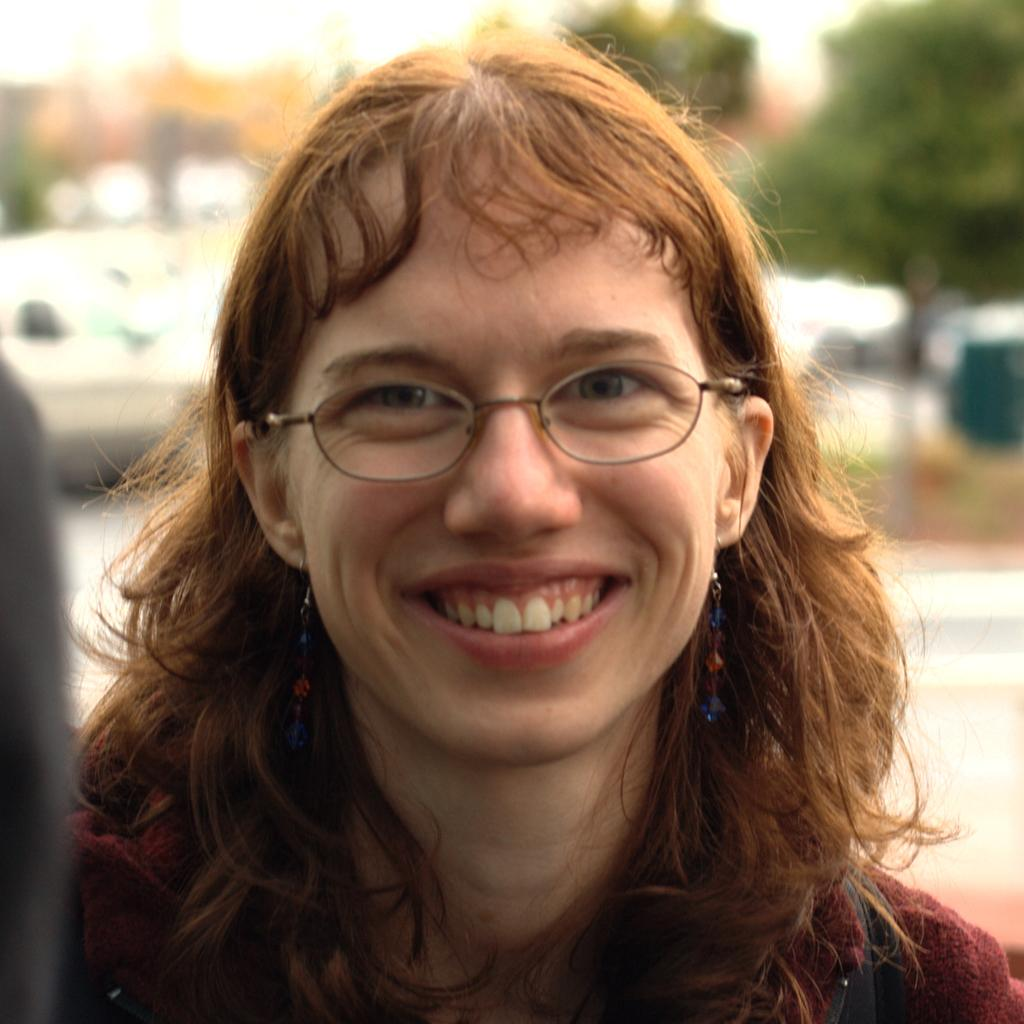Who or what is the main subject of the image? There is a person in the image. What is the person wearing? The person is wearing a maroon color dress. Are there any accessories visible on the person? Yes, the person is wearing specs. What can be seen in the background of the image? There are trees visible in the background of the image. How would you describe the background of the image? The background of the image is blurred. Can you tell me how many pigs are visible in the image? There are no pigs present in the image. What type of curve can be seen in the person's dress in the image? The person's dress is described as maroon color, but there is no mention of any curves in the dress. --- Facts: 1. There is a car in the image. 2. The car is red. 3. The car has four wheels. 4. There are people in the car. 5. The car is parked on the side of the road. Absurd Topics: fish, mountain, bicycle Conversation: What is the main subject of the image? The main subject of the image is a car. What color is the car? The car is red. How many wheels does the car have? The car has four wheels. Are there any passengers in the car? Yes, there are people in the car. Where is the car located in the image? The car is parked on the side of the road. Reasoning: Let's think step by step in order to produce the conversation. We start by identifying the main subject of the image, which is the car. Then, we describe the car's color and number of wheels. Next, we mention the presence of passengers in the car. Finally, we describe the car's location in the image, noting that it is parked on the side of the road. Absurd Question/Answer: How many fish can be seen swimming in the car in the image? There are no fish present in the image, and the car is parked, not filled with water. What type of mountain can be seen in the background of the image? There is no mountain visible in the image; it only shows a car parked on the side of the road. --- Facts: 1. There is a dog in the image. 2. The dog is brown. 3. The dog is sitting on a chair. 4. There is a table in the image. 5. The table has a book on it. Absurd Topics: parrot, ocean, guitar Conversation: What is the main subject of the image? The main subject of the image is a dog. What color is the dog? The dog is brown. 